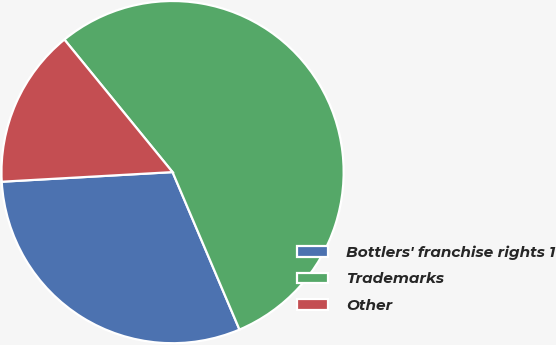<chart> <loc_0><loc_0><loc_500><loc_500><pie_chart><fcel>Bottlers' franchise rights 1<fcel>Trademarks<fcel>Other<nl><fcel>30.5%<fcel>54.5%<fcel>15.0%<nl></chart> 